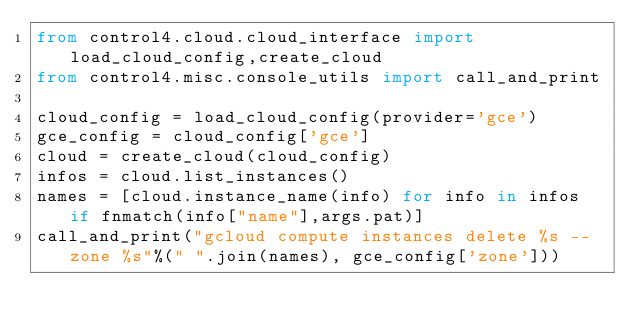Convert code to text. <code><loc_0><loc_0><loc_500><loc_500><_Python_>from control4.cloud.cloud_interface import load_cloud_config,create_cloud
from control4.misc.console_utils import call_and_print

cloud_config = load_cloud_config(provider='gce')
gce_config = cloud_config['gce']
cloud = create_cloud(cloud_config)
infos = cloud.list_instances()
names = [cloud.instance_name(info) for info in infos if fnmatch(info["name"],args.pat)]
call_and_print("gcloud compute instances delete %s --zone %s"%(" ".join(names), gce_config['zone']))
</code> 